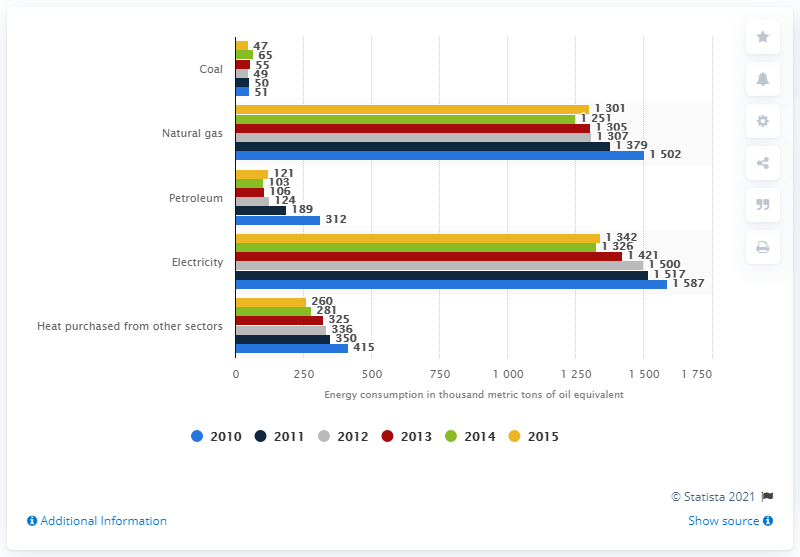Outline some significant characteristics in this image. Between 2010 and 2015, the chemicals industry consumed a total of 1,342 million barrels of oil equivalent. The chemicals industry consumed how much oil equivalent from 2010 to 2015? 